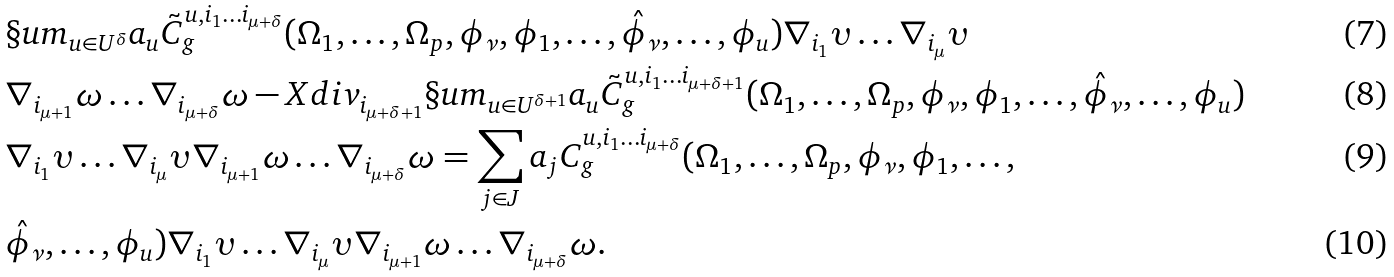Convert formula to latex. <formula><loc_0><loc_0><loc_500><loc_500>& \S u m _ { u \in U ^ { \delta } } a _ { u } \tilde { C } ^ { u , i _ { 1 } \dots i _ { \mu + \delta } } _ { g } ( \Omega _ { 1 } , \dots , \Omega _ { p } , \phi _ { \nu } , \phi _ { 1 } , \dots , \hat { \phi } _ { \nu } , \dots , \phi _ { u } ) \nabla _ { i _ { 1 } } \upsilon \dots \nabla _ { i _ { \mu } } \upsilon \\ & \nabla _ { i _ { \mu + 1 } } \omega \dots \nabla _ { i _ { \mu + \delta } } \omega - X d i v _ { i _ { \mu + \delta + 1 } } \S u m _ { u \in U ^ { \delta + 1 } } a _ { u } \tilde { C } ^ { u , i _ { 1 } \dots i _ { \mu + \delta + 1 } } _ { g } ( \Omega _ { 1 } , \dots , \Omega _ { p } , \phi _ { \nu } , \phi _ { 1 } , \dots , \hat { \phi } _ { \nu } , \dots , \phi _ { u } ) \\ & \nabla _ { i _ { 1 } } \upsilon \dots \nabla _ { i _ { \mu } } \upsilon \nabla _ { i _ { \mu + 1 } } \omega \dots \nabla _ { i _ { \mu + \delta } } \omega = \sum _ { j \in J } a _ { j } C ^ { u , i _ { 1 } \dots i _ { \mu + \delta } } _ { g } ( \Omega _ { 1 } , \dots , \Omega _ { p } , \phi _ { \nu } , \phi _ { 1 } , \dots , \\ & \hat { \phi } _ { \nu } , \dots , \phi _ { u } ) \nabla _ { i _ { 1 } } \upsilon \dots \nabla _ { i _ { \mu } } \upsilon \nabla _ { i _ { \mu + 1 } } \omega \dots \nabla _ { i _ { \mu + \delta } } \omega .</formula> 